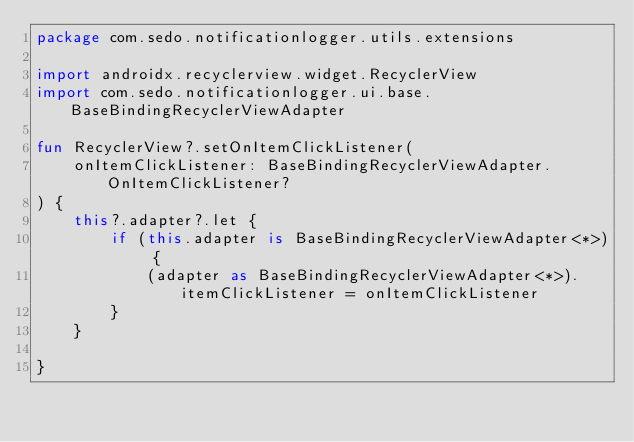Convert code to text. <code><loc_0><loc_0><loc_500><loc_500><_Kotlin_>package com.sedo.notificationlogger.utils.extensions

import androidx.recyclerview.widget.RecyclerView
import com.sedo.notificationlogger.ui.base.BaseBindingRecyclerViewAdapter

fun RecyclerView?.setOnItemClickListener(
    onItemClickListener: BaseBindingRecyclerViewAdapter.OnItemClickListener?
) {
    this?.adapter?.let {
        if (this.adapter is BaseBindingRecyclerViewAdapter<*>) {
            (adapter as BaseBindingRecyclerViewAdapter<*>).itemClickListener = onItemClickListener
        }
    }

}</code> 